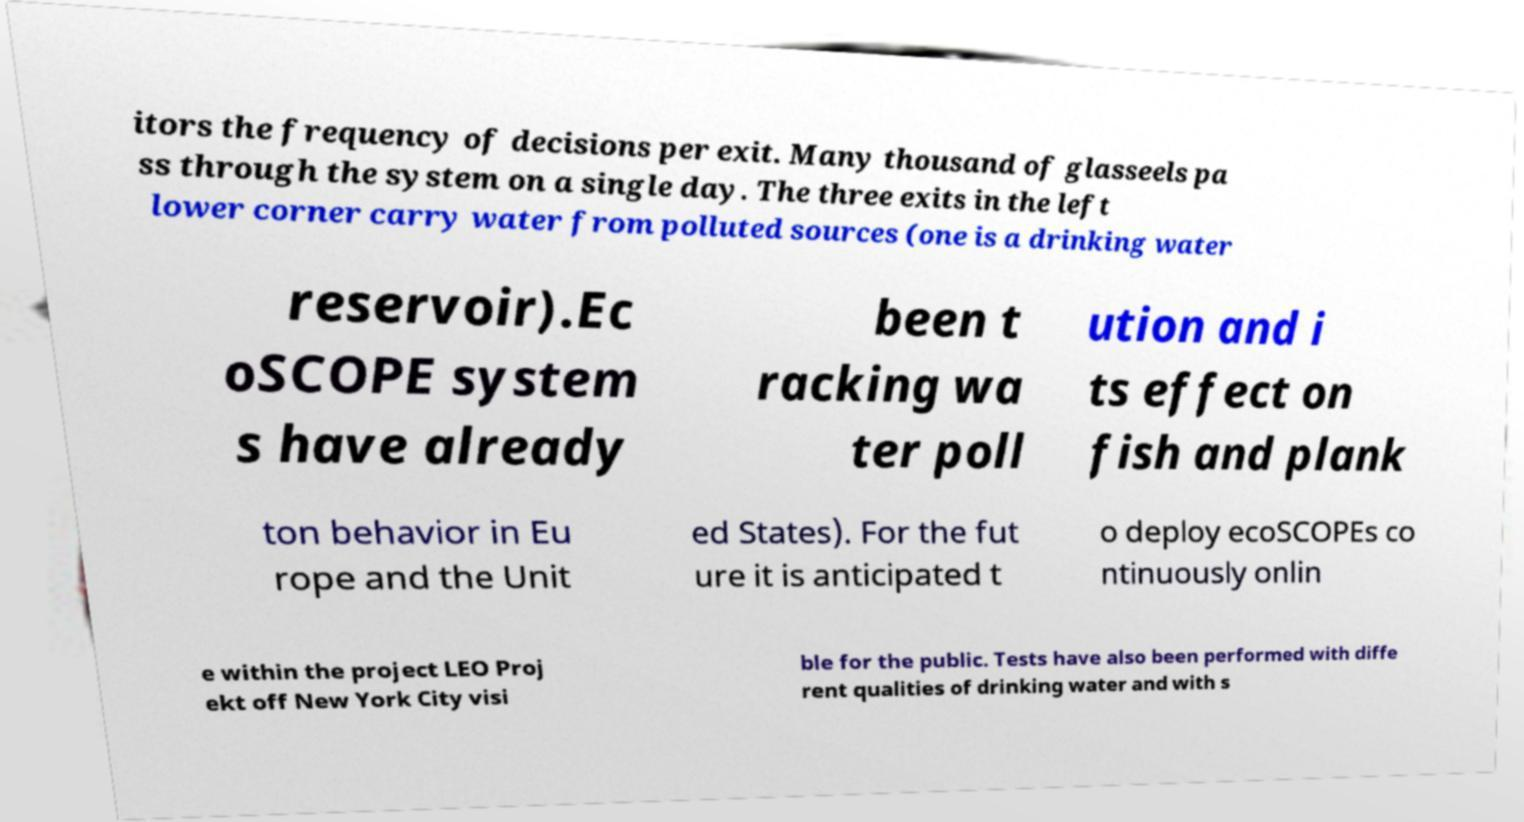Please identify and transcribe the text found in this image. itors the frequency of decisions per exit. Many thousand of glasseels pa ss through the system on a single day. The three exits in the left lower corner carry water from polluted sources (one is a drinking water reservoir).Ec oSCOPE system s have already been t racking wa ter poll ution and i ts effect on fish and plank ton behavior in Eu rope and the Unit ed States). For the fut ure it is anticipated t o deploy ecoSCOPEs co ntinuously onlin e within the project LEO Proj ekt off New York City visi ble for the public. Tests have also been performed with diffe rent qualities of drinking water and with s 